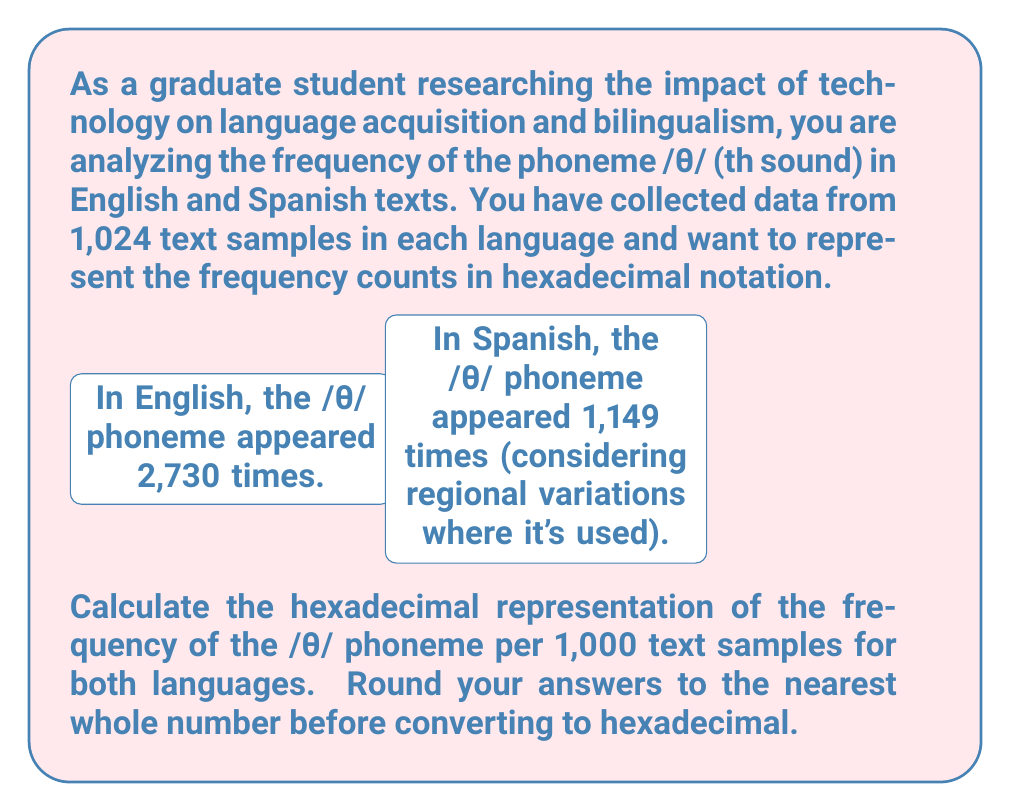Can you answer this question? Let's approach this step-by-step:

1. Calculate the frequency per 1,000 samples for English:
   $$\text{Frequency}_{\text{English}} = \frac{2,730 \text{ occurrences}}{1,024 \text{ samples}} \times 1,000 = 2,666.015625$$
   Rounding to the nearest whole number: 2,666

2. Calculate the frequency per 1,000 samples for Spanish:
   $$\text{Frequency}_{\text{Spanish}} = \frac{1,149 \text{ occurrences}}{1,024 \text{ samples}} \times 1,000 = 1,122.0703125$$
   Rounding to the nearest whole number: 1,122

3. Convert 2,666 to hexadecimal:
   2,666 ÷ 16 = 166 remainder 10 (A)
   166 ÷ 16 = 10 remainder 6
   10 ÷ 16 = 0 remainder 10 (A)
   So, 2,666 in hexadecimal is $A6A_{16}$

4. Convert 1,122 to hexadecimal:
   1,122 ÷ 16 = 70 remainder 2
   70 ÷ 16 = 4 remainder 6
   4 ÷ 16 = 0 remainder 4
   So, 1,122 in hexadecimal is $462_{16}$

Therefore, the hexadecimal representation of the /θ/ phoneme frequency per 1,000 text samples is $A6A_{16}$ for English and $462_{16}$ for Spanish.
Answer: English: $A6A_{16}$, Spanish: $462_{16}$ 